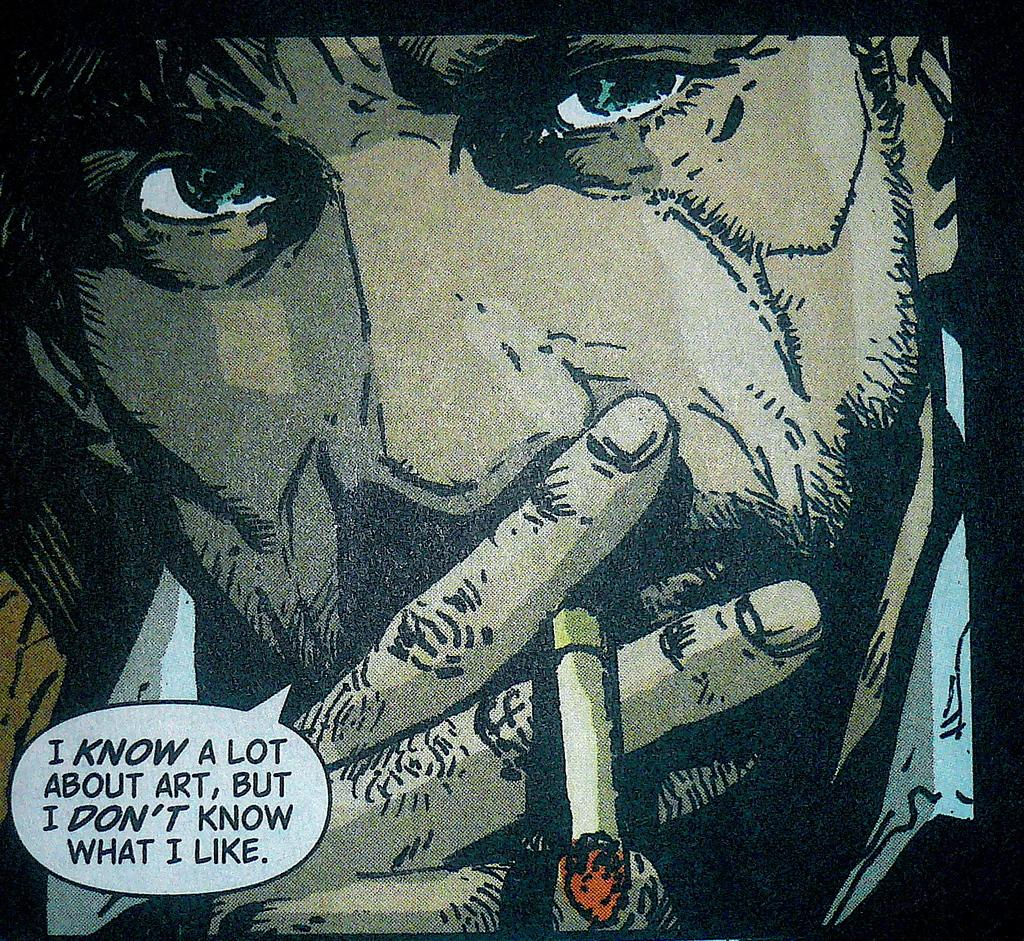Who is present in the image? There is a man in the image. What is the man doing in the image? The man is smoking in the image. What can be seen on the left side of the image? There is text on the left side of the image. How is the image created? The image appears to be a painting. What type of pie is being served on the table in the image? There is no table or pie present in the image; it features a man smoking and text on the left side. 